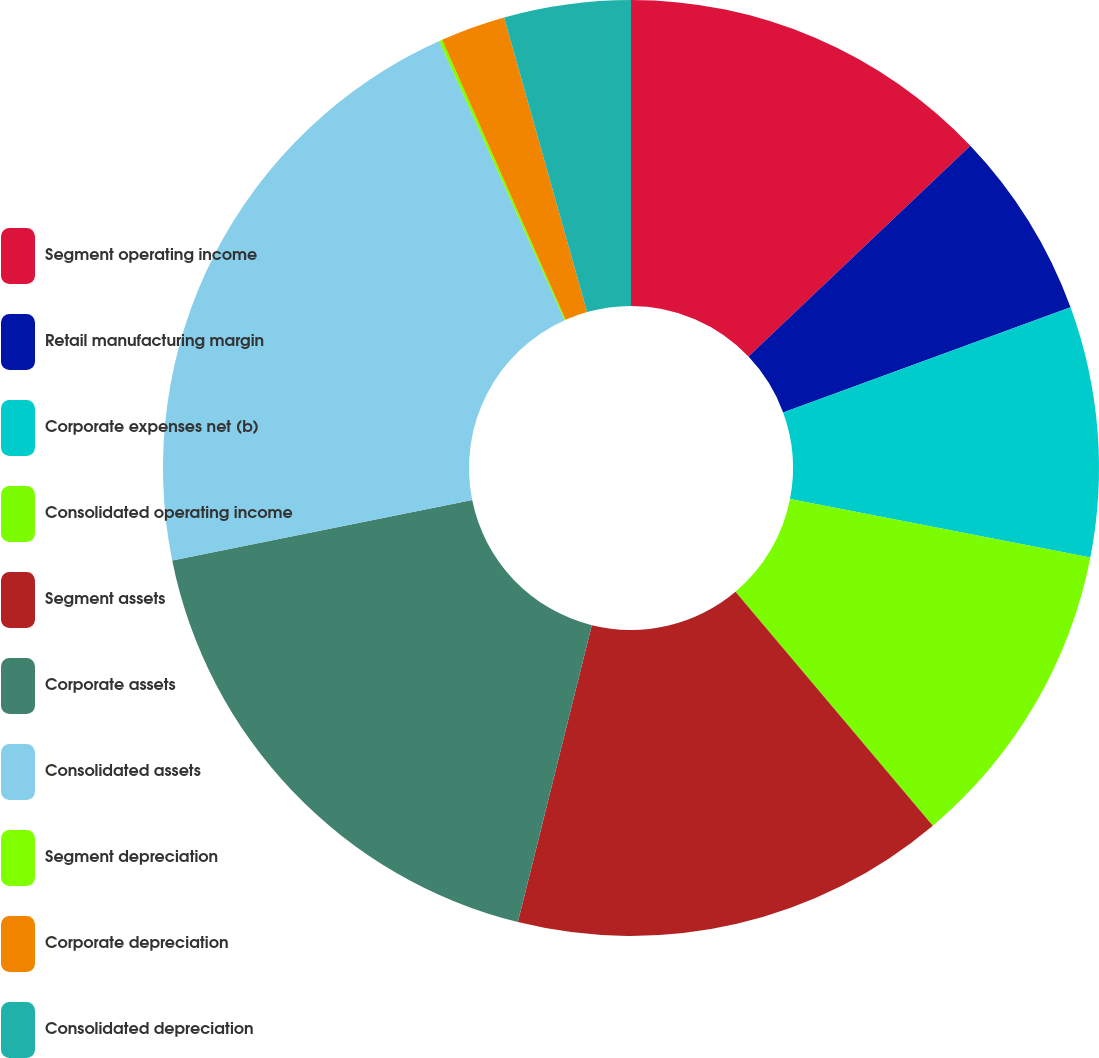Convert chart. <chart><loc_0><loc_0><loc_500><loc_500><pie_chart><fcel>Segment operating income<fcel>Retail manufacturing margin<fcel>Corporate expenses net (b)<fcel>Consolidated operating income<fcel>Segment assets<fcel>Corporate assets<fcel>Consolidated assets<fcel>Segment depreciation<fcel>Corporate depreciation<fcel>Consolidated depreciation<nl><fcel>12.91%<fcel>6.51%<fcel>8.64%<fcel>10.78%<fcel>15.04%<fcel>17.95%<fcel>21.44%<fcel>0.11%<fcel>2.24%<fcel>4.37%<nl></chart> 